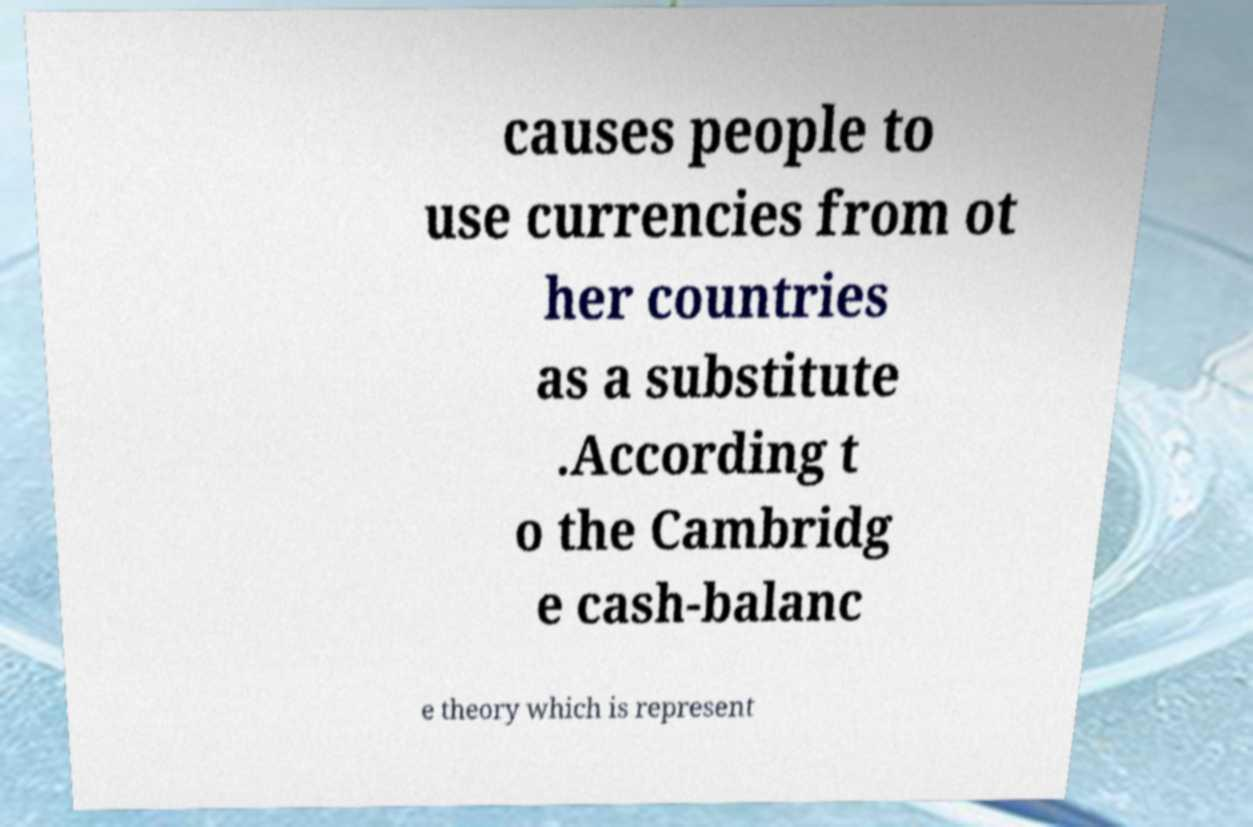Can you accurately transcribe the text from the provided image for me? causes people to use currencies from ot her countries as a substitute .According t o the Cambridg e cash-balanc e theory which is represent 